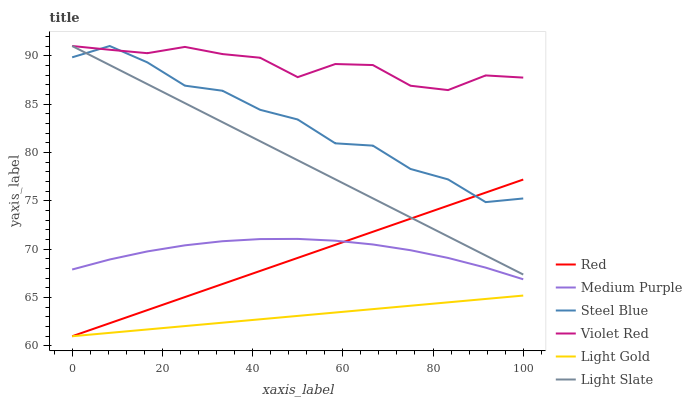Does Light Gold have the minimum area under the curve?
Answer yes or no. Yes. Does Violet Red have the maximum area under the curve?
Answer yes or no. Yes. Does Light Slate have the minimum area under the curve?
Answer yes or no. No. Does Light Slate have the maximum area under the curve?
Answer yes or no. No. Is Red the smoothest?
Answer yes or no. Yes. Is Steel Blue the roughest?
Answer yes or no. Yes. Is Light Slate the smoothest?
Answer yes or no. No. Is Light Slate the roughest?
Answer yes or no. No. Does Light Gold have the lowest value?
Answer yes or no. Yes. Does Light Slate have the lowest value?
Answer yes or no. No. Does Steel Blue have the highest value?
Answer yes or no. Yes. Does Medium Purple have the highest value?
Answer yes or no. No. Is Medium Purple less than Violet Red?
Answer yes or no. Yes. Is Violet Red greater than Medium Purple?
Answer yes or no. Yes. Does Steel Blue intersect Red?
Answer yes or no. Yes. Is Steel Blue less than Red?
Answer yes or no. No. Is Steel Blue greater than Red?
Answer yes or no. No. Does Medium Purple intersect Violet Red?
Answer yes or no. No. 